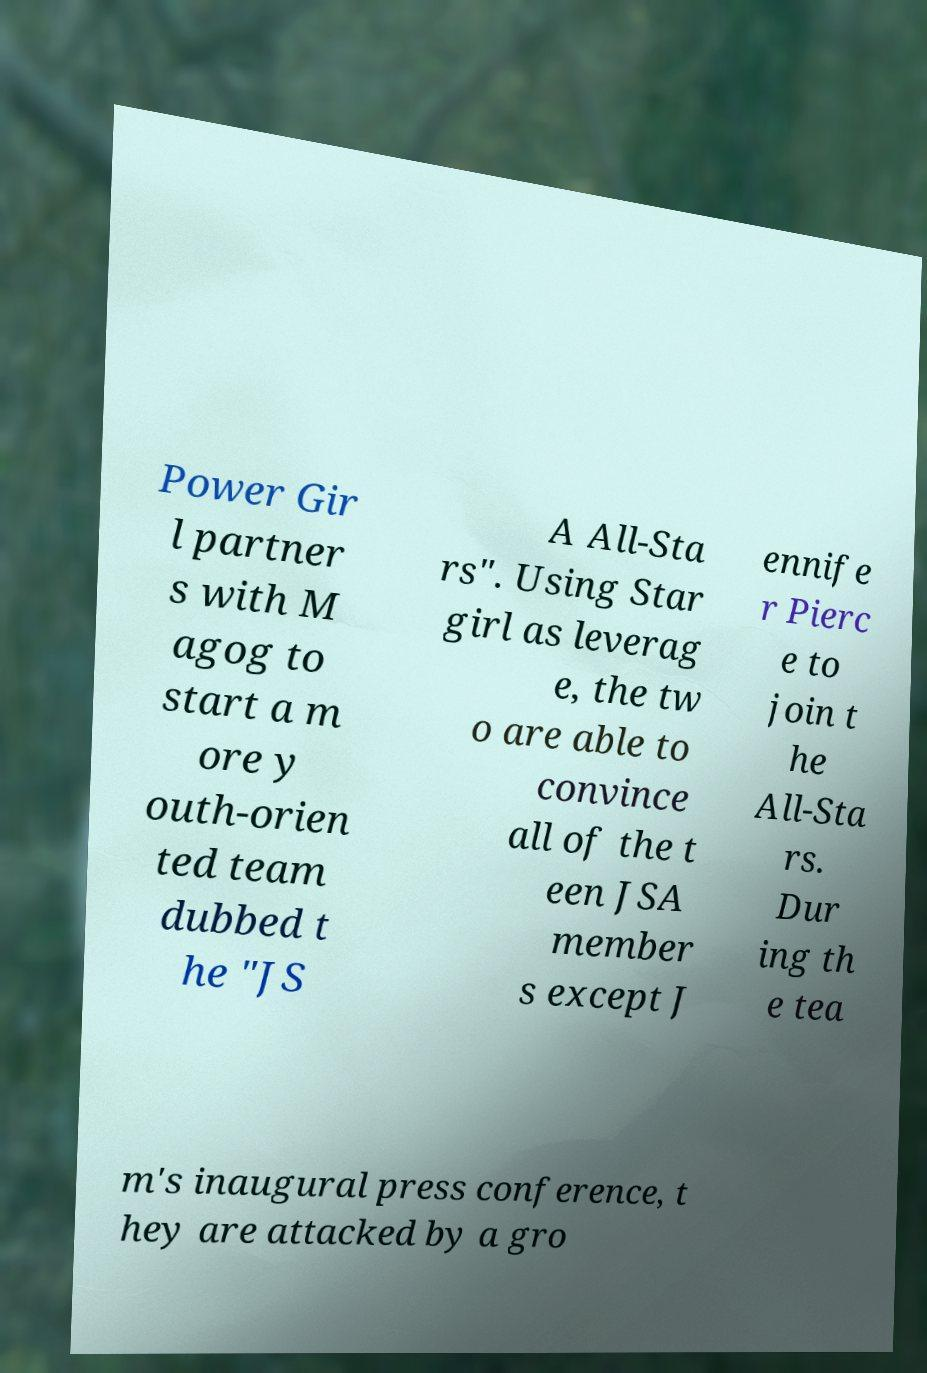Could you assist in decoding the text presented in this image and type it out clearly? Power Gir l partner s with M agog to start a m ore y outh-orien ted team dubbed t he "JS A All-Sta rs". Using Star girl as leverag e, the tw o are able to convince all of the t een JSA member s except J ennife r Pierc e to join t he All-Sta rs. Dur ing th e tea m's inaugural press conference, t hey are attacked by a gro 